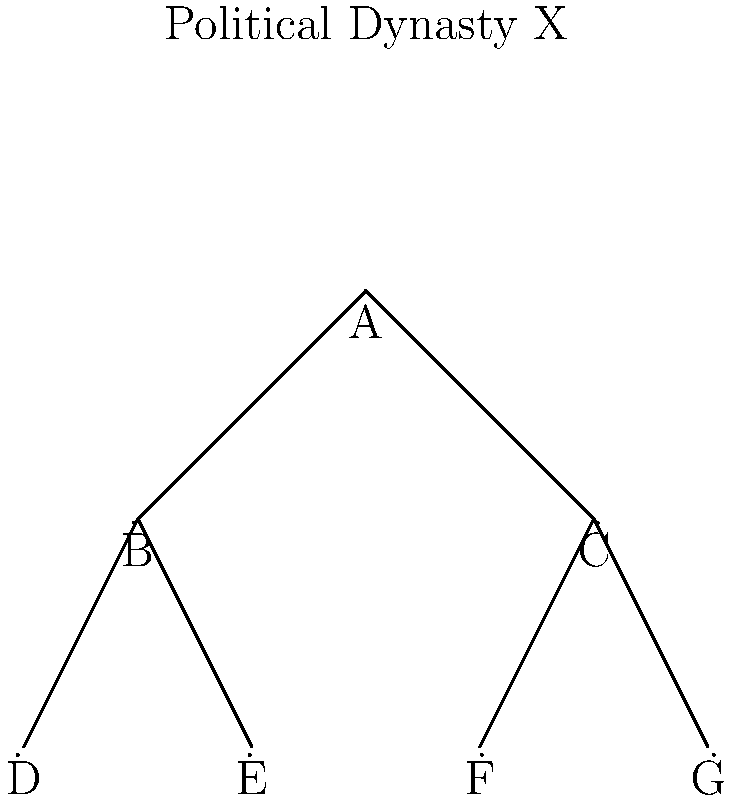In the family tree of Political Dynasty X shown above, how many different paths can be traced from the root (A) to the leaves (D, E, F, G) of the tree? What does this reveal about the potential for influence and power distribution within the dynasty? To solve this problem, we need to analyze the structure of the family tree and count the number of unique paths from the root to each leaf. Let's break it down step-by-step:

1. Identify the root and leaves:
   Root: A
   Leaves: D, E, F, G

2. Trace paths from root to leaves:
   Path 1: A -> B -> D
   Path 2: A -> B -> E
   Path 3: A -> C -> F
   Path 4: A -> C -> G

3. Count the number of unique paths:
   There are 4 distinct paths from the root to the leaves.

4. Interpret the results:
   - Each path represents a line of succession or influence within the dynasty.
   - The number of paths (4) indicates the potential for diversification of power and influence.
   - Two main branches (B and C) suggest two primary sub-families or factions within the dynasty.
   - The balanced structure (2 children each for B and C) implies a relatively even distribution of power between these sub-families.

5. Political implications:
   - Multiple paths can lead to complex power dynamics and potential rivalries.
   - The structure allows for different strategies in maintaining and expanding influence.
   - The even distribution might promote stability but could also lead to power struggles between the two main branches.

This analysis reveals that Political Dynasty X has a structured and balanced approach to power distribution, with multiple potential lines of succession or influence. This structure could be used to maintain a strong grip on power across different sectors or regions, while also potentially creating internal competition for resources and influence.
Answer: 4 paths; balanced power distribution with potential for complex dynamics 